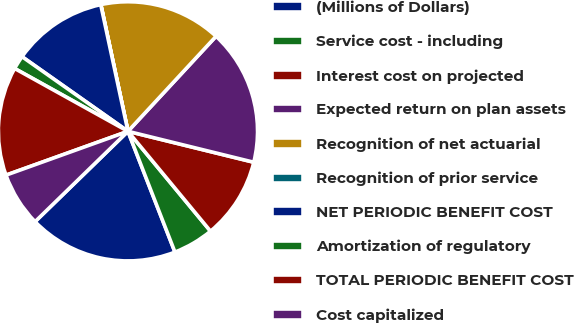<chart> <loc_0><loc_0><loc_500><loc_500><pie_chart><fcel>(Millions of Dollars)<fcel>Service cost - including<fcel>Interest cost on projected<fcel>Expected return on plan assets<fcel>Recognition of net actuarial<fcel>Recognition of prior service<fcel>NET PERIODIC BENEFIT COST<fcel>Amortization of regulatory<fcel>TOTAL PERIODIC BENEFIT COST<fcel>Cost capitalized<nl><fcel>18.63%<fcel>5.09%<fcel>10.17%<fcel>16.94%<fcel>15.25%<fcel>0.02%<fcel>11.86%<fcel>1.71%<fcel>13.55%<fcel>6.79%<nl></chart> 